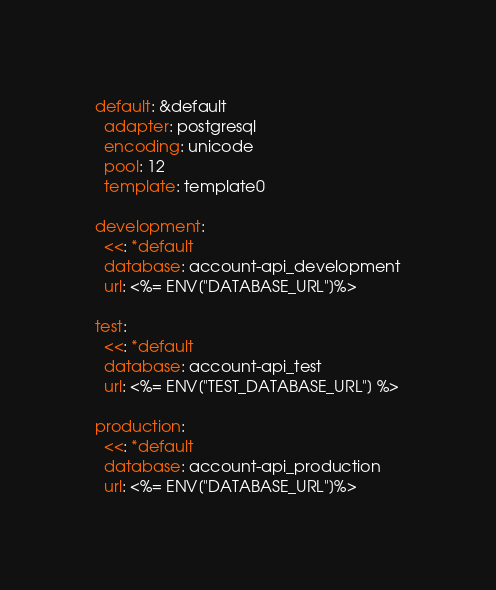<code> <loc_0><loc_0><loc_500><loc_500><_YAML_>default: &default
  adapter: postgresql
  encoding: unicode
  pool: 12
  template: template0

development:
  <<: *default
  database: account-api_development
  url: <%= ENV["DATABASE_URL"]%>

test:
  <<: *default
  database: account-api_test
  url: <%= ENV["TEST_DATABASE_URL"] %>

production:
  <<: *default
  database: account-api_production
  url: <%= ENV["DATABASE_URL"]%>
</code> 